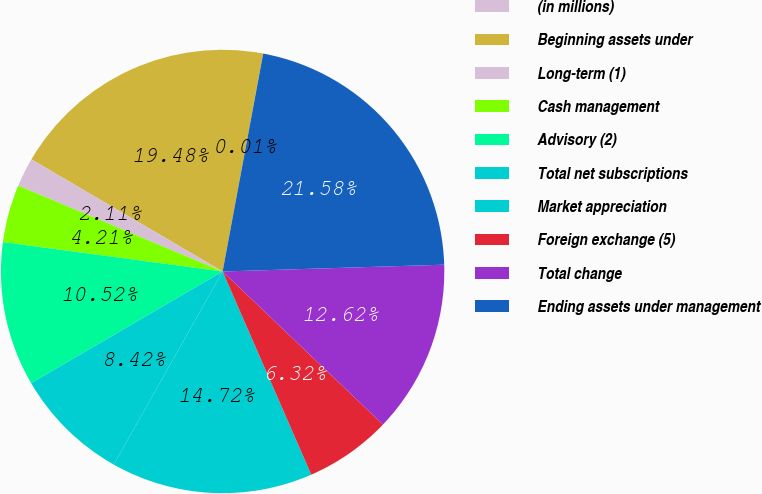<chart> <loc_0><loc_0><loc_500><loc_500><pie_chart><fcel>(in millions)<fcel>Beginning assets under<fcel>Long-term (1)<fcel>Cash management<fcel>Advisory (2)<fcel>Total net subscriptions<fcel>Market appreciation<fcel>Foreign exchange (5)<fcel>Total change<fcel>Ending assets under management<nl><fcel>0.01%<fcel>19.48%<fcel>2.11%<fcel>4.21%<fcel>10.52%<fcel>8.42%<fcel>14.72%<fcel>6.32%<fcel>12.62%<fcel>21.58%<nl></chart> 